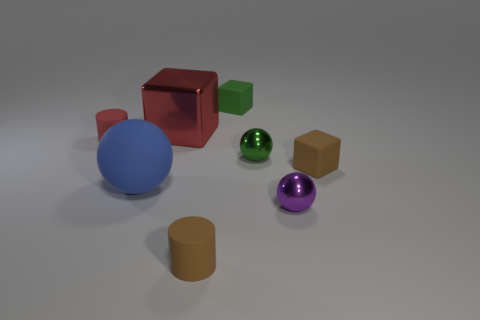Add 1 small red cylinders. How many objects exist? 9 Subtract all large blue balls. How many balls are left? 2 Subtract all gray blocks. How many brown spheres are left? 0 Add 2 green cubes. How many green cubes exist? 3 Subtract all red cylinders. How many cylinders are left? 1 Subtract 0 blue cubes. How many objects are left? 8 Subtract all spheres. How many objects are left? 5 Subtract 3 blocks. How many blocks are left? 0 Subtract all red cylinders. Subtract all blue blocks. How many cylinders are left? 1 Subtract all red cubes. Subtract all small brown rubber cylinders. How many objects are left? 6 